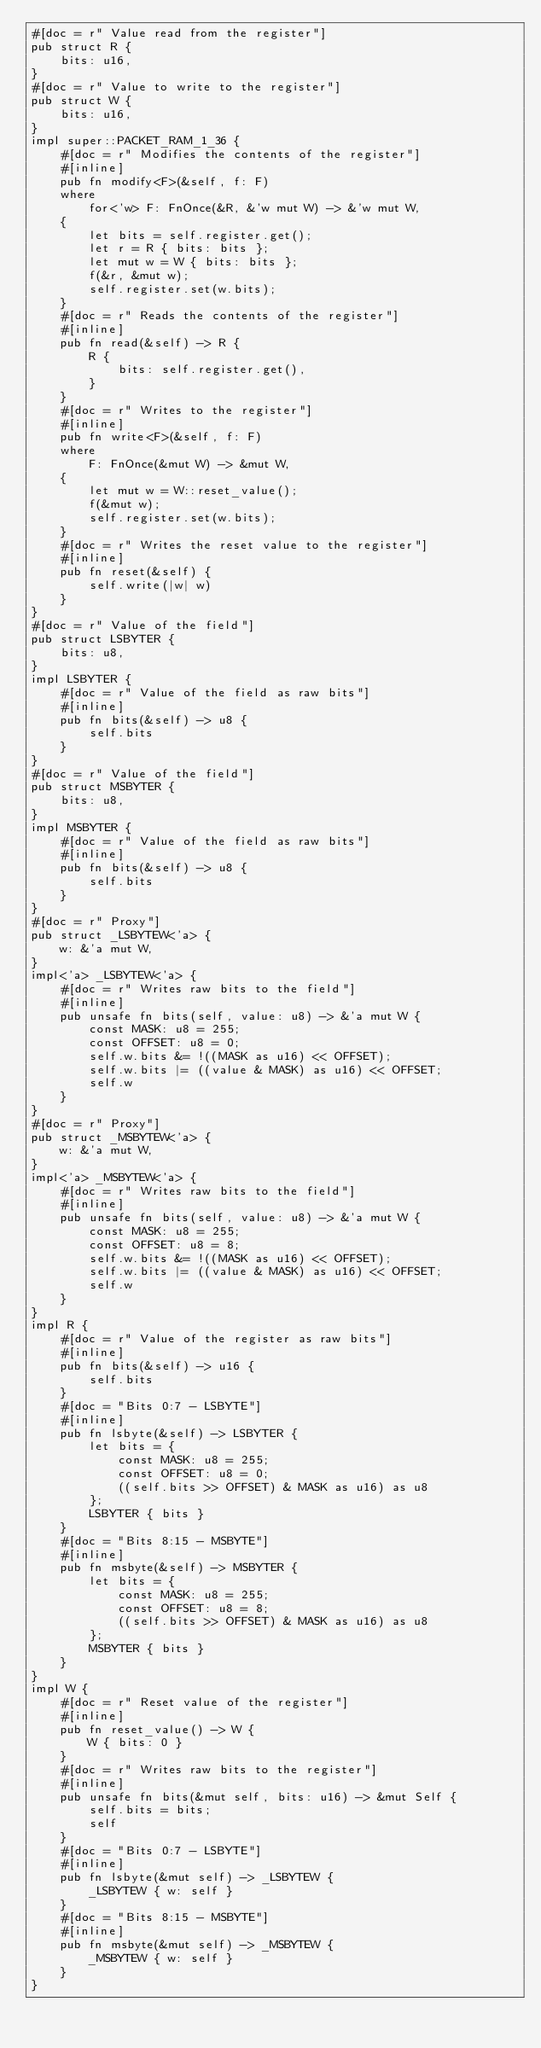<code> <loc_0><loc_0><loc_500><loc_500><_Rust_>#[doc = r" Value read from the register"]
pub struct R {
    bits: u16,
}
#[doc = r" Value to write to the register"]
pub struct W {
    bits: u16,
}
impl super::PACKET_RAM_1_36 {
    #[doc = r" Modifies the contents of the register"]
    #[inline]
    pub fn modify<F>(&self, f: F)
    where
        for<'w> F: FnOnce(&R, &'w mut W) -> &'w mut W,
    {
        let bits = self.register.get();
        let r = R { bits: bits };
        let mut w = W { bits: bits };
        f(&r, &mut w);
        self.register.set(w.bits);
    }
    #[doc = r" Reads the contents of the register"]
    #[inline]
    pub fn read(&self) -> R {
        R {
            bits: self.register.get(),
        }
    }
    #[doc = r" Writes to the register"]
    #[inline]
    pub fn write<F>(&self, f: F)
    where
        F: FnOnce(&mut W) -> &mut W,
    {
        let mut w = W::reset_value();
        f(&mut w);
        self.register.set(w.bits);
    }
    #[doc = r" Writes the reset value to the register"]
    #[inline]
    pub fn reset(&self) {
        self.write(|w| w)
    }
}
#[doc = r" Value of the field"]
pub struct LSBYTER {
    bits: u8,
}
impl LSBYTER {
    #[doc = r" Value of the field as raw bits"]
    #[inline]
    pub fn bits(&self) -> u8 {
        self.bits
    }
}
#[doc = r" Value of the field"]
pub struct MSBYTER {
    bits: u8,
}
impl MSBYTER {
    #[doc = r" Value of the field as raw bits"]
    #[inline]
    pub fn bits(&self) -> u8 {
        self.bits
    }
}
#[doc = r" Proxy"]
pub struct _LSBYTEW<'a> {
    w: &'a mut W,
}
impl<'a> _LSBYTEW<'a> {
    #[doc = r" Writes raw bits to the field"]
    #[inline]
    pub unsafe fn bits(self, value: u8) -> &'a mut W {
        const MASK: u8 = 255;
        const OFFSET: u8 = 0;
        self.w.bits &= !((MASK as u16) << OFFSET);
        self.w.bits |= ((value & MASK) as u16) << OFFSET;
        self.w
    }
}
#[doc = r" Proxy"]
pub struct _MSBYTEW<'a> {
    w: &'a mut W,
}
impl<'a> _MSBYTEW<'a> {
    #[doc = r" Writes raw bits to the field"]
    #[inline]
    pub unsafe fn bits(self, value: u8) -> &'a mut W {
        const MASK: u8 = 255;
        const OFFSET: u8 = 8;
        self.w.bits &= !((MASK as u16) << OFFSET);
        self.w.bits |= ((value & MASK) as u16) << OFFSET;
        self.w
    }
}
impl R {
    #[doc = r" Value of the register as raw bits"]
    #[inline]
    pub fn bits(&self) -> u16 {
        self.bits
    }
    #[doc = "Bits 0:7 - LSBYTE"]
    #[inline]
    pub fn lsbyte(&self) -> LSBYTER {
        let bits = {
            const MASK: u8 = 255;
            const OFFSET: u8 = 0;
            ((self.bits >> OFFSET) & MASK as u16) as u8
        };
        LSBYTER { bits }
    }
    #[doc = "Bits 8:15 - MSBYTE"]
    #[inline]
    pub fn msbyte(&self) -> MSBYTER {
        let bits = {
            const MASK: u8 = 255;
            const OFFSET: u8 = 8;
            ((self.bits >> OFFSET) & MASK as u16) as u8
        };
        MSBYTER { bits }
    }
}
impl W {
    #[doc = r" Reset value of the register"]
    #[inline]
    pub fn reset_value() -> W {
        W { bits: 0 }
    }
    #[doc = r" Writes raw bits to the register"]
    #[inline]
    pub unsafe fn bits(&mut self, bits: u16) -> &mut Self {
        self.bits = bits;
        self
    }
    #[doc = "Bits 0:7 - LSBYTE"]
    #[inline]
    pub fn lsbyte(&mut self) -> _LSBYTEW {
        _LSBYTEW { w: self }
    }
    #[doc = "Bits 8:15 - MSBYTE"]
    #[inline]
    pub fn msbyte(&mut self) -> _MSBYTEW {
        _MSBYTEW { w: self }
    }
}
</code> 